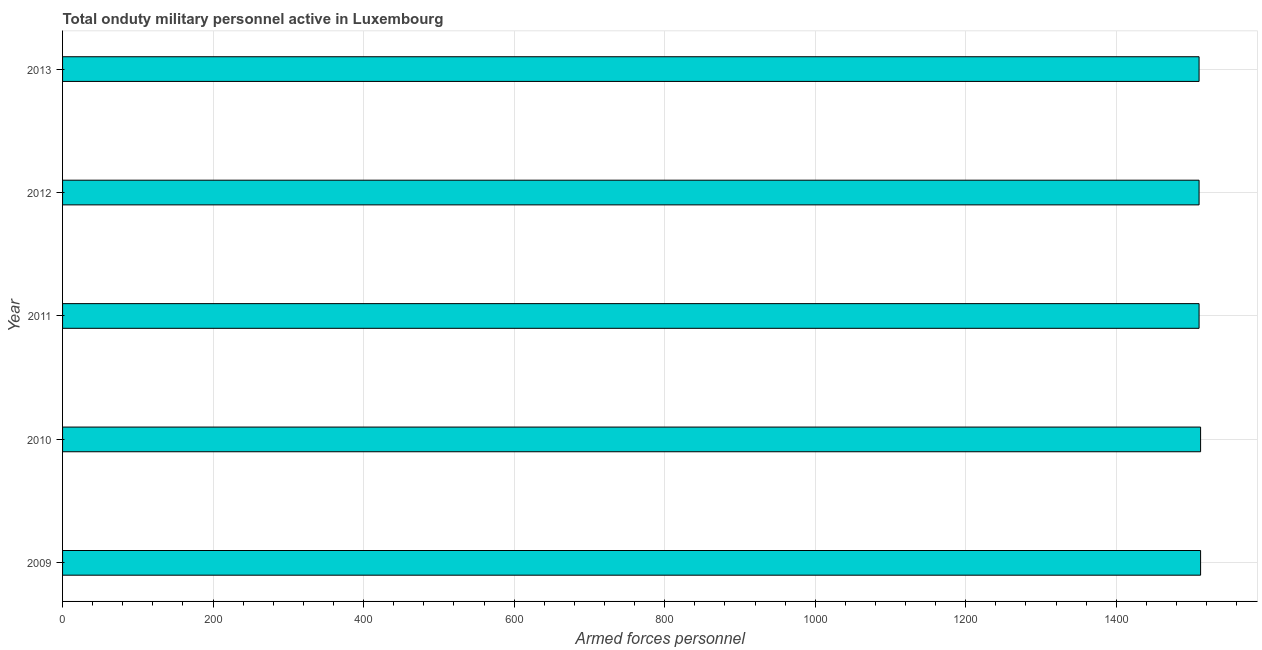Does the graph contain grids?
Provide a succinct answer. Yes. What is the title of the graph?
Offer a very short reply. Total onduty military personnel active in Luxembourg. What is the label or title of the X-axis?
Offer a very short reply. Armed forces personnel. What is the number of armed forces personnel in 2013?
Provide a succinct answer. 1510. Across all years, what is the maximum number of armed forces personnel?
Provide a succinct answer. 1512. Across all years, what is the minimum number of armed forces personnel?
Offer a very short reply. 1510. In which year was the number of armed forces personnel maximum?
Offer a terse response. 2009. In which year was the number of armed forces personnel minimum?
Make the answer very short. 2011. What is the sum of the number of armed forces personnel?
Provide a short and direct response. 7554. What is the difference between the number of armed forces personnel in 2011 and 2013?
Give a very brief answer. 0. What is the average number of armed forces personnel per year?
Your response must be concise. 1510. What is the median number of armed forces personnel?
Your response must be concise. 1510. What is the ratio of the number of armed forces personnel in 2009 to that in 2013?
Give a very brief answer. 1. Is the number of armed forces personnel in 2009 less than that in 2012?
Offer a very short reply. No. Is the difference between the number of armed forces personnel in 2009 and 2012 greater than the difference between any two years?
Your response must be concise. Yes. What is the difference between the highest and the second highest number of armed forces personnel?
Ensure brevity in your answer.  0. How many bars are there?
Provide a succinct answer. 5. Are all the bars in the graph horizontal?
Your answer should be very brief. Yes. How many years are there in the graph?
Make the answer very short. 5. What is the difference between two consecutive major ticks on the X-axis?
Give a very brief answer. 200. Are the values on the major ticks of X-axis written in scientific E-notation?
Your response must be concise. No. What is the Armed forces personnel of 2009?
Your answer should be compact. 1512. What is the Armed forces personnel in 2010?
Make the answer very short. 1512. What is the Armed forces personnel in 2011?
Your answer should be very brief. 1510. What is the Armed forces personnel of 2012?
Offer a very short reply. 1510. What is the Armed forces personnel of 2013?
Provide a short and direct response. 1510. What is the difference between the Armed forces personnel in 2009 and 2010?
Give a very brief answer. 0. What is the difference between the Armed forces personnel in 2009 and 2013?
Your answer should be very brief. 2. What is the difference between the Armed forces personnel in 2010 and 2012?
Provide a succinct answer. 2. What is the difference between the Armed forces personnel in 2011 and 2012?
Your response must be concise. 0. What is the difference between the Armed forces personnel in 2011 and 2013?
Provide a short and direct response. 0. What is the difference between the Armed forces personnel in 2012 and 2013?
Provide a short and direct response. 0. What is the ratio of the Armed forces personnel in 2009 to that in 2010?
Provide a succinct answer. 1. What is the ratio of the Armed forces personnel in 2010 to that in 2011?
Provide a succinct answer. 1. What is the ratio of the Armed forces personnel in 2010 to that in 2012?
Provide a short and direct response. 1. What is the ratio of the Armed forces personnel in 2010 to that in 2013?
Offer a terse response. 1. What is the ratio of the Armed forces personnel in 2011 to that in 2013?
Make the answer very short. 1. 